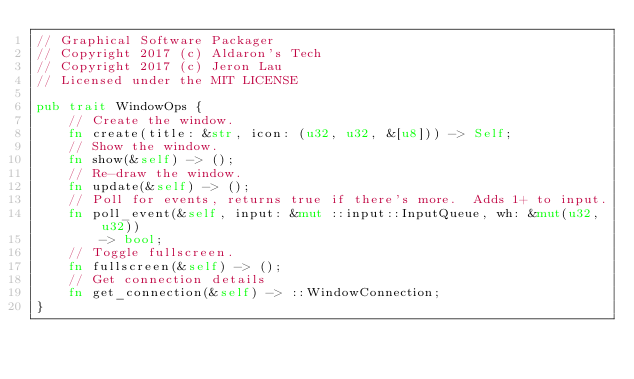<code> <loc_0><loc_0><loc_500><loc_500><_Rust_>// Graphical Software Packager
// Copyright 2017 (c) Aldaron's Tech
// Copyright 2017 (c) Jeron Lau
// Licensed under the MIT LICENSE

pub trait WindowOps {
	// Create the window.
	fn create(title: &str, icon: (u32, u32, &[u8])) -> Self;
	// Show the window.
	fn show(&self) -> ();
	// Re-draw the window.
	fn update(&self) -> ();
	// Poll for events, returns true if there's more.  Adds 1+ to input.
	fn poll_event(&self, input: &mut ::input::InputQueue, wh: &mut(u32,u32))
		-> bool;
	// Toggle fullscreen.
	fn fullscreen(&self) -> ();
	// Get connection details
	fn get_connection(&self) -> ::WindowConnection;
}
</code> 